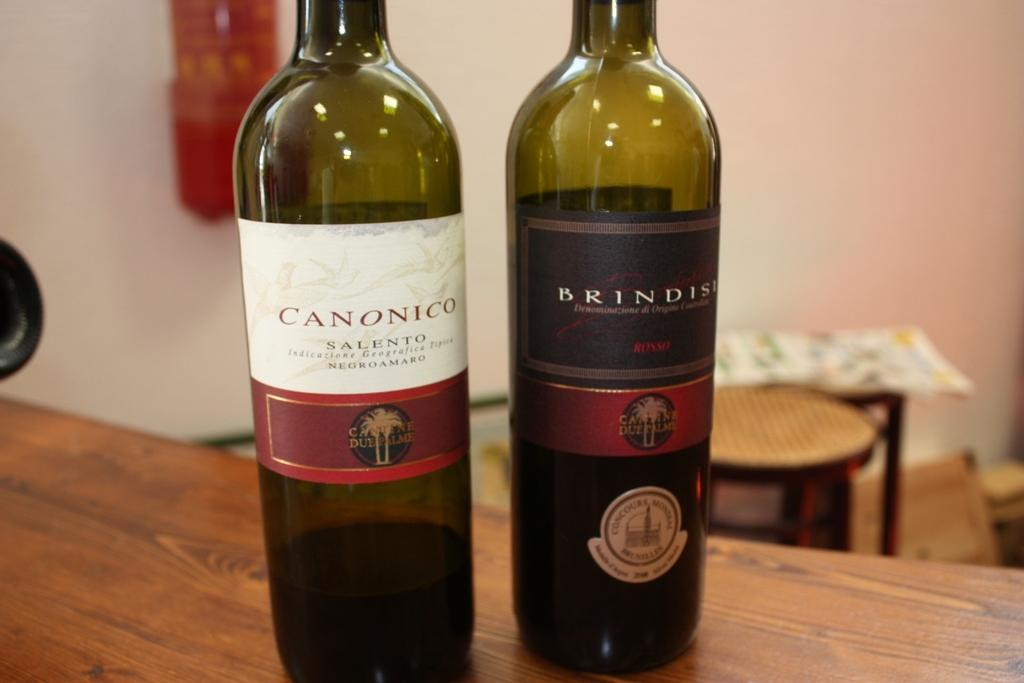<image>
Present a compact description of the photo's key features. Two bottles of wine, negroamaro and rosso, are on the wooden table towards the edge. 